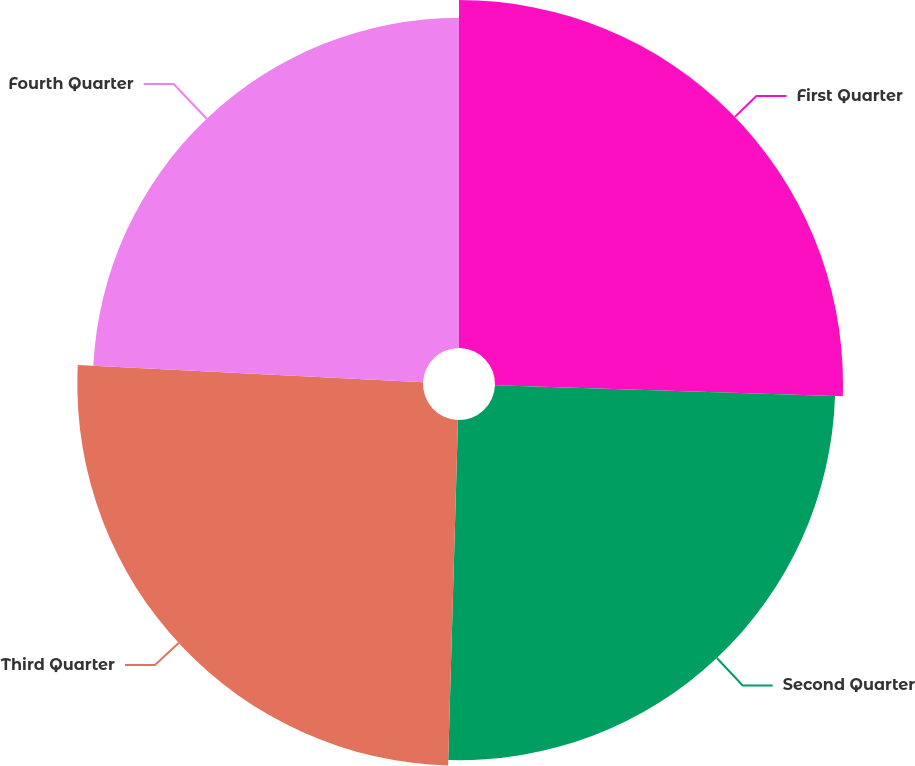Convert chart to OTSL. <chart><loc_0><loc_0><loc_500><loc_500><pie_chart><fcel>First Quarter<fcel>Second Quarter<fcel>Third Quarter<fcel>Fourth Quarter<nl><fcel>25.51%<fcel>24.94%<fcel>25.34%<fcel>24.2%<nl></chart> 